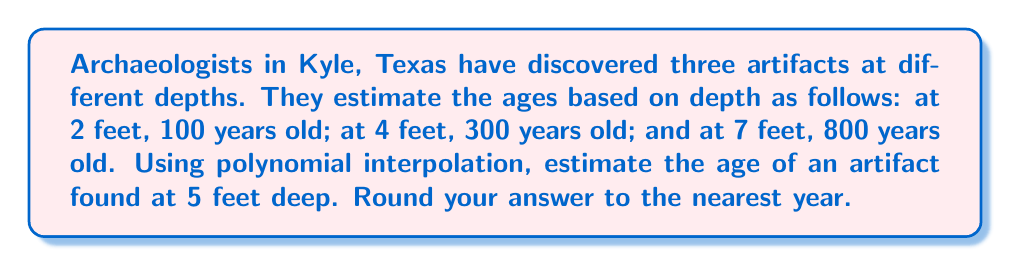Teach me how to tackle this problem. Let's approach this step-by-step using Lagrange polynomial interpolation:

1) We have three data points: $(2, 100)$, $(4, 300)$, and $(7, 800)$.

2) The Lagrange interpolation polynomial is:

   $$P(x) = y_1\frac{(x-x_2)(x-x_3)}{(x_1-x_2)(x_1-x_3)} + y_2\frac{(x-x_1)(x-x_3)}{(x_2-x_1)(x_2-x_3)} + y_3\frac{(x-x_1)(x-x_2)}{(x_3-x_1)(x_3-x_2)}$$

3) Substituting our values:

   $$P(x) = 100\frac{(x-4)(x-7)}{(2-4)(2-7)} + 300\frac{(x-2)(x-7)}{(4-2)(4-7)} + 800\frac{(x-2)(x-4)}{(7-2)(7-4)}$$

4) Simplifying:

   $$P(x) = 100\frac{(x-4)(x-7)}{(-2)(-5)} + 300\frac{(x-2)(x-7)}{(2)(-3)} + 800\frac{(x-2)(x-4)}{(5)(3)}$$

   $$P(x) = 10(x-4)(x-7) - 50(x-2)(x-7) + \frac{160}{3}(x-2)(x-4)$$

5) Expanding:

   $$P(x) = 10(x^2-11x+28) - 50(x^2-9x+14) + \frac{160}{3}(x^2-6x+8)$$
   
   $$P(x) = 10x^2-110x+280 - 50x^2+450x-700 + \frac{160}{3}x^2-320x+\frac{1280}{3}$$

6) Combining like terms:

   $$P(x) = \frac{10}{3}x^2 + 20x + \frac{420}{3}$$

7) Now, we want to find $P(5)$:

   $$P(5) = \frac{10}{3}(25) + 20(5) + \frac{420}{3} = \frac{250}{3} + 100 + 140 = \frac{250}{3} + \frac{300}{3} + \frac{420}{3} = \frac{970}{3} \approx 323.33$$

8) Rounding to the nearest year:

   323 years
Answer: 323 years 